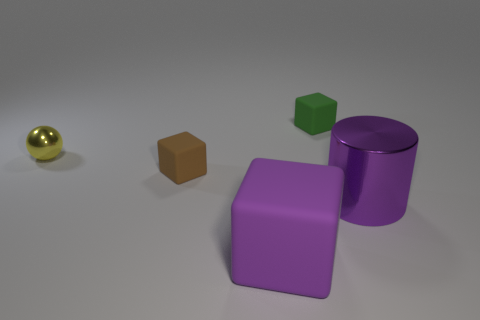Is the color of the tiny metal thing the same as the large cube?
Give a very brief answer. No. How many things are spheres or big things in front of the big purple metal cylinder?
Offer a terse response. 2. There is a matte block that is in front of the rubber block that is on the left side of the purple cube; what number of matte objects are behind it?
Your answer should be compact. 2. What is the material of the object that is the same color as the cylinder?
Provide a short and direct response. Rubber. How many big purple matte cubes are there?
Offer a terse response. 1. There is a metal object that is on the left side of the green matte block; is it the same size as the small brown cube?
Offer a terse response. Yes. What number of metallic things are either small brown blocks or cubes?
Your response must be concise. 0. What number of purple objects are on the right side of the matte thing that is to the right of the big purple rubber object?
Provide a succinct answer. 1. The object that is on the left side of the large block and behind the brown thing has what shape?
Provide a succinct answer. Sphere. What material is the big object that is behind the cube in front of the cylinder to the right of the yellow shiny thing?
Ensure brevity in your answer.  Metal. 